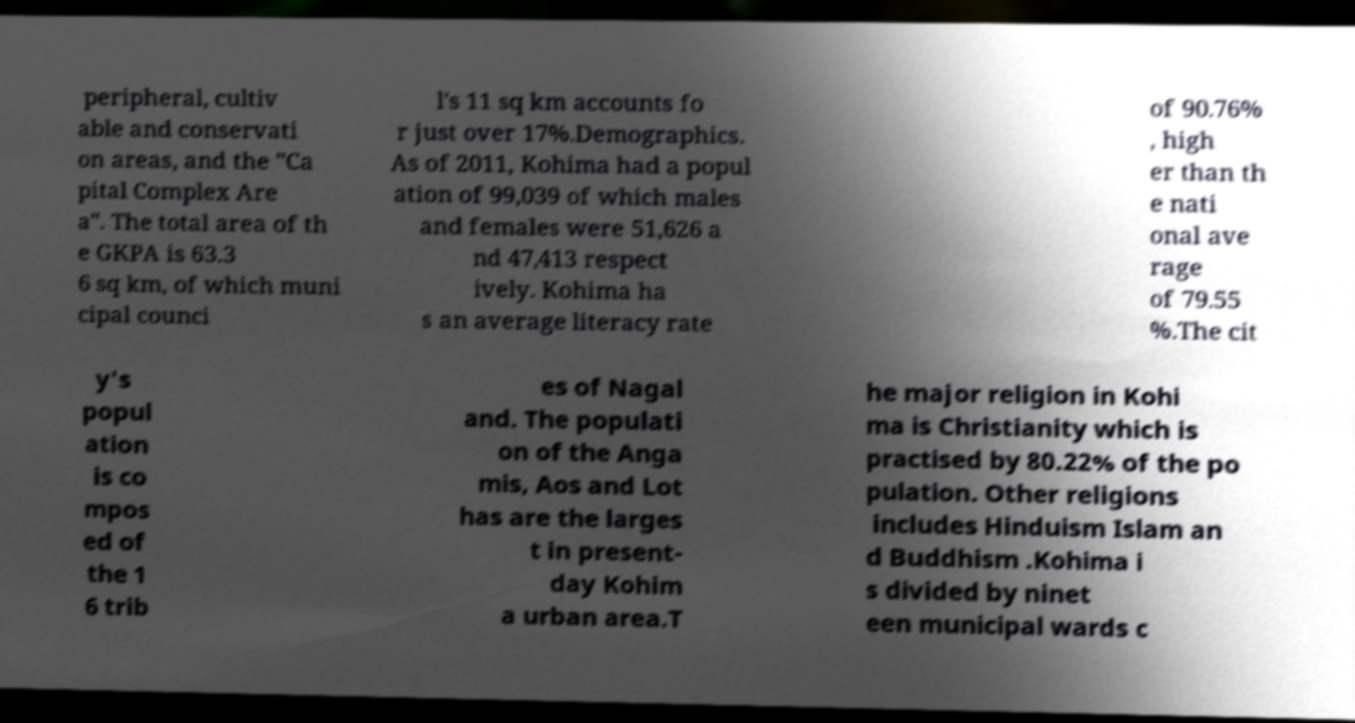For documentation purposes, I need the text within this image transcribed. Could you provide that? peripheral, cultiv able and conservati on areas, and the "Ca pital Complex Are a". The total area of th e GKPA is 63.3 6 sq km, of which muni cipal counci l's 11 sq km accounts fo r just over 17%.Demographics. As of 2011, Kohima had a popul ation of 99,039 of which males and females were 51,626 a nd 47,413 respect ively. Kohima ha s an average literacy rate of 90.76% , high er than th e nati onal ave rage of 79.55 %.The cit y's popul ation is co mpos ed of the 1 6 trib es of Nagal and. The populati on of the Anga mis, Aos and Lot has are the larges t in present- day Kohim a urban area.T he major religion in Kohi ma is Christianity which is practised by 80.22% of the po pulation. Other religions includes Hinduism Islam an d Buddhism .Kohima i s divided by ninet een municipal wards c 